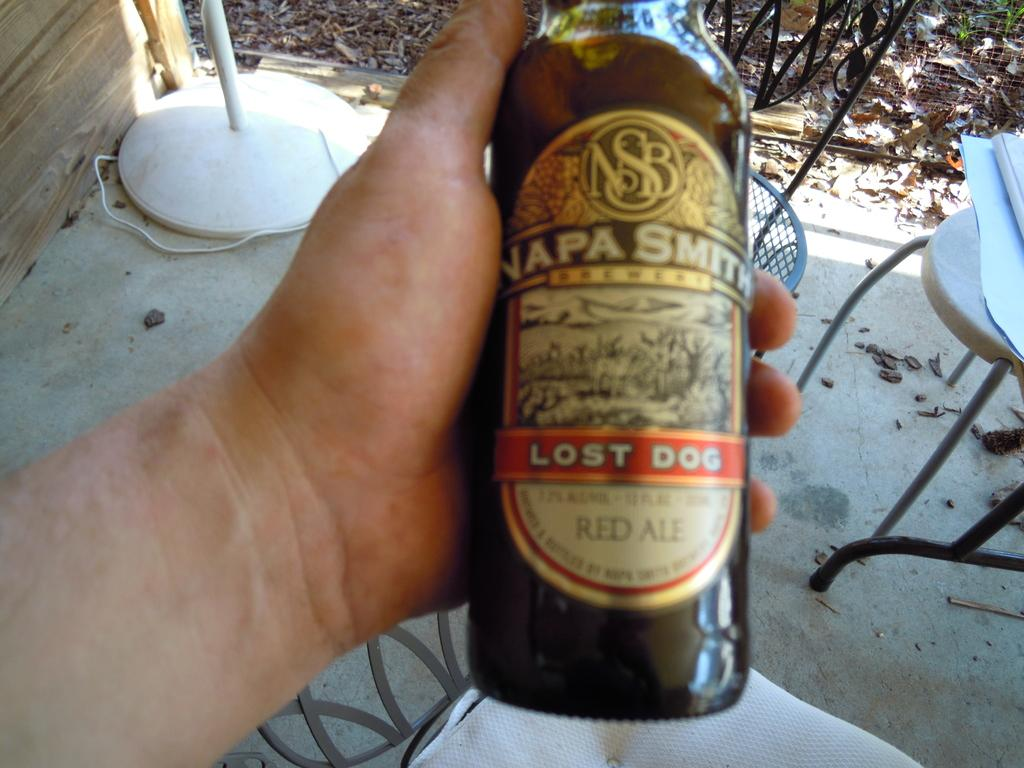<image>
Relay a brief, clear account of the picture shown. a bottle of beer called napa smith being held by a person 